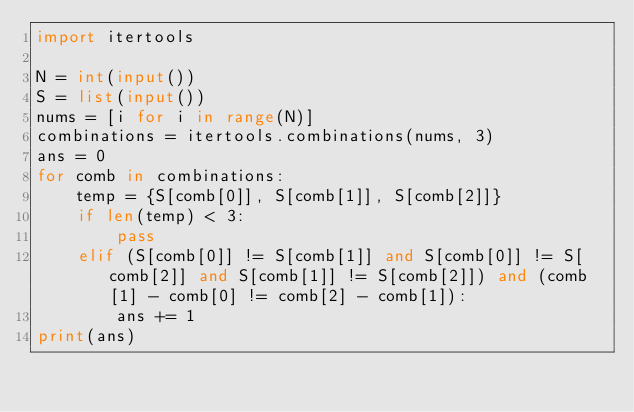Convert code to text. <code><loc_0><loc_0><loc_500><loc_500><_Python_>import itertools
 
N = int(input())
S = list(input())
nums = [i for i in range(N)]
combinations = itertools.combinations(nums, 3)
ans = 0
for comb in combinations:
    temp = {S[comb[0]], S[comb[1]], S[comb[2]]}
    if len(temp) < 3:
        pass
    elif (S[comb[0]] != S[comb[1]] and S[comb[0]] != S[comb[2]] and S[comb[1]] != S[comb[2]]) and (comb[1] - comb[0] != comb[2] - comb[1]):
        ans += 1
print(ans)</code> 